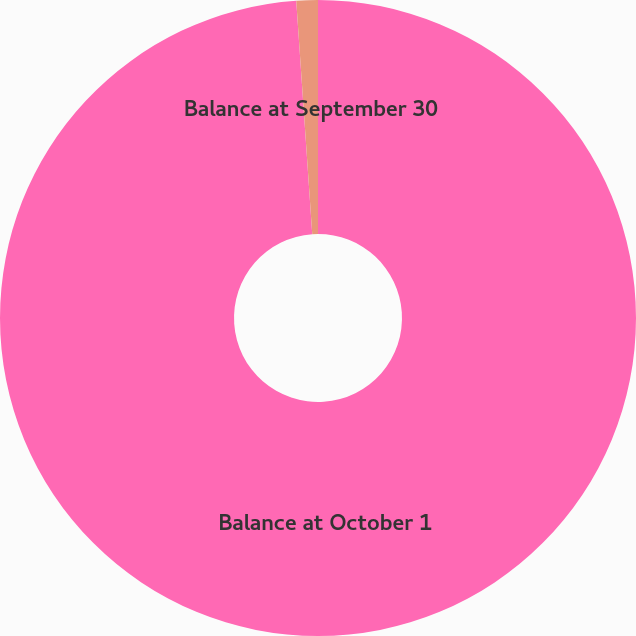Convert chart. <chart><loc_0><loc_0><loc_500><loc_500><pie_chart><fcel>Balance at October 1<fcel>Balance at September 30<nl><fcel>98.91%<fcel>1.09%<nl></chart> 